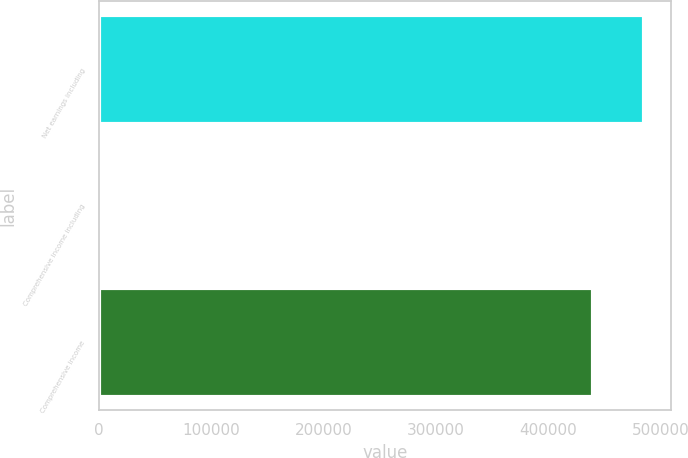<chart> <loc_0><loc_0><loc_500><loc_500><bar_chart><fcel>Net earnings including<fcel>Comprehensive income including<fcel>Comprehensive income<nl><fcel>484972<fcel>2354<fcel>440127<nl></chart> 